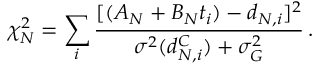<formula> <loc_0><loc_0><loc_500><loc_500>\chi _ { N } ^ { 2 } = \sum _ { i } \frac { [ ( A _ { N } + B _ { N } t _ { i } ) - d _ { N , i } ] ^ { 2 } } { \sigma ^ { 2 } ( d _ { N , i } ^ { C } ) + \sigma _ { G } ^ { 2 } } \, .</formula> 